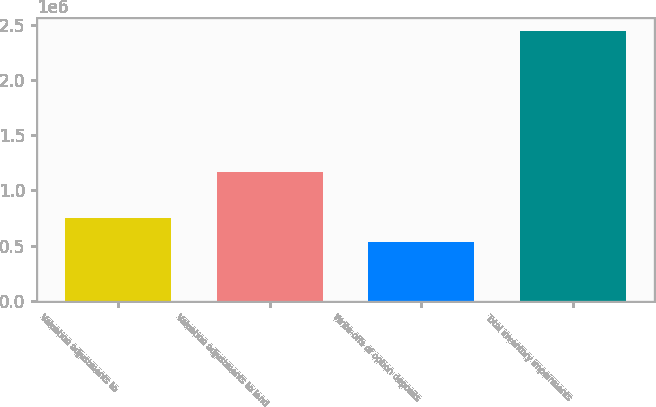Convert chart. <chart><loc_0><loc_0><loc_500><loc_500><bar_chart><fcel>Valuation adjustments to<fcel>Valuation adjustments to land<fcel>Write-offs of option deposits<fcel>Total inventory impairments<nl><fcel>747843<fcel>1.16729e+06<fcel>529981<fcel>2.44512e+06<nl></chart> 